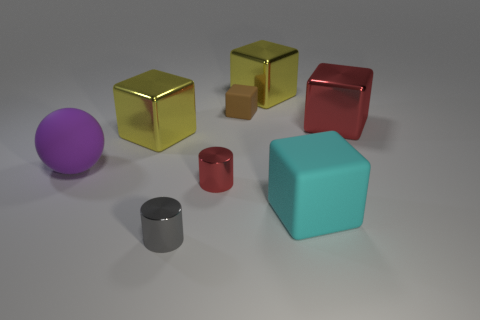Is the material of the small gray cylinder the same as the large cyan thing?
Your answer should be very brief. No. What number of things are small matte things or small brown cylinders?
Make the answer very short. 1. The brown rubber thing is what size?
Provide a succinct answer. Small. Is the number of large purple things less than the number of tiny red shiny balls?
Your response must be concise. No. What number of large rubber cubes have the same color as the small rubber thing?
Ensure brevity in your answer.  0. There is a yellow thing that is to the right of the tiny gray thing; what shape is it?
Offer a very short reply. Cube. Is there a red metallic cylinder right of the big rubber object behind the cyan matte thing?
Provide a succinct answer. Yes. What number of small things have the same material as the red block?
Keep it short and to the point. 2. There is a red shiny thing that is to the left of the big yellow shiny object that is behind the red thing behind the large purple object; what size is it?
Offer a terse response. Small. There is a tiny brown rubber object; how many small brown objects are to the left of it?
Offer a very short reply. 0. 